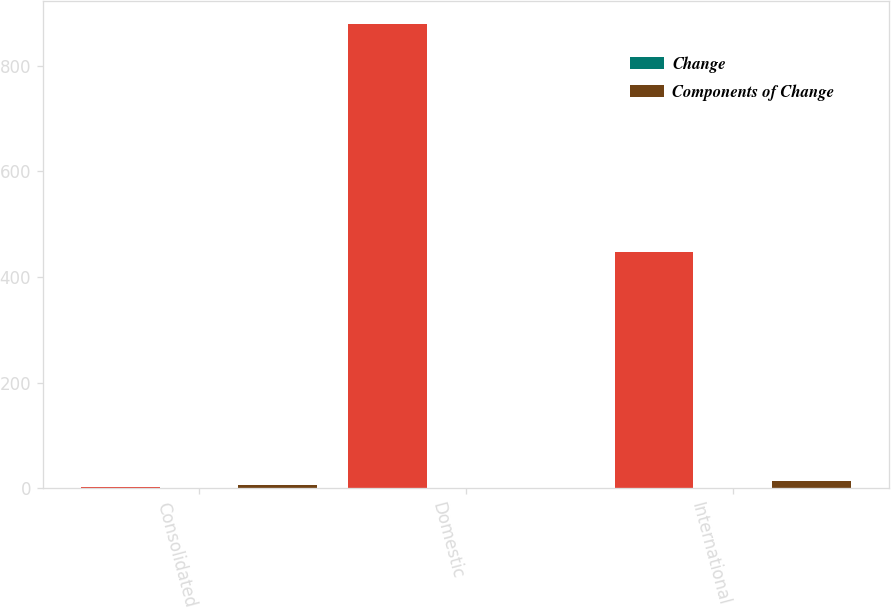Convert chart. <chart><loc_0><loc_0><loc_500><loc_500><stacked_bar_chart><ecel><fcel>Consolidated<fcel>Domestic<fcel>International<nl><fcel>nan<fcel>3.75<fcel>878.6<fcel>448.1<nl><fcel>Change<fcel>1.2<fcel>0<fcel>1.2<nl><fcel>Components of Change<fcel>5.8<fcel>1.7<fcel>14<nl></chart> 